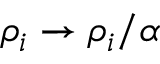Convert formula to latex. <formula><loc_0><loc_0><loc_500><loc_500>\rho _ { i } \to \rho _ { i } / \alpha</formula> 